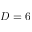Convert formula to latex. <formula><loc_0><loc_0><loc_500><loc_500>D = 6</formula> 